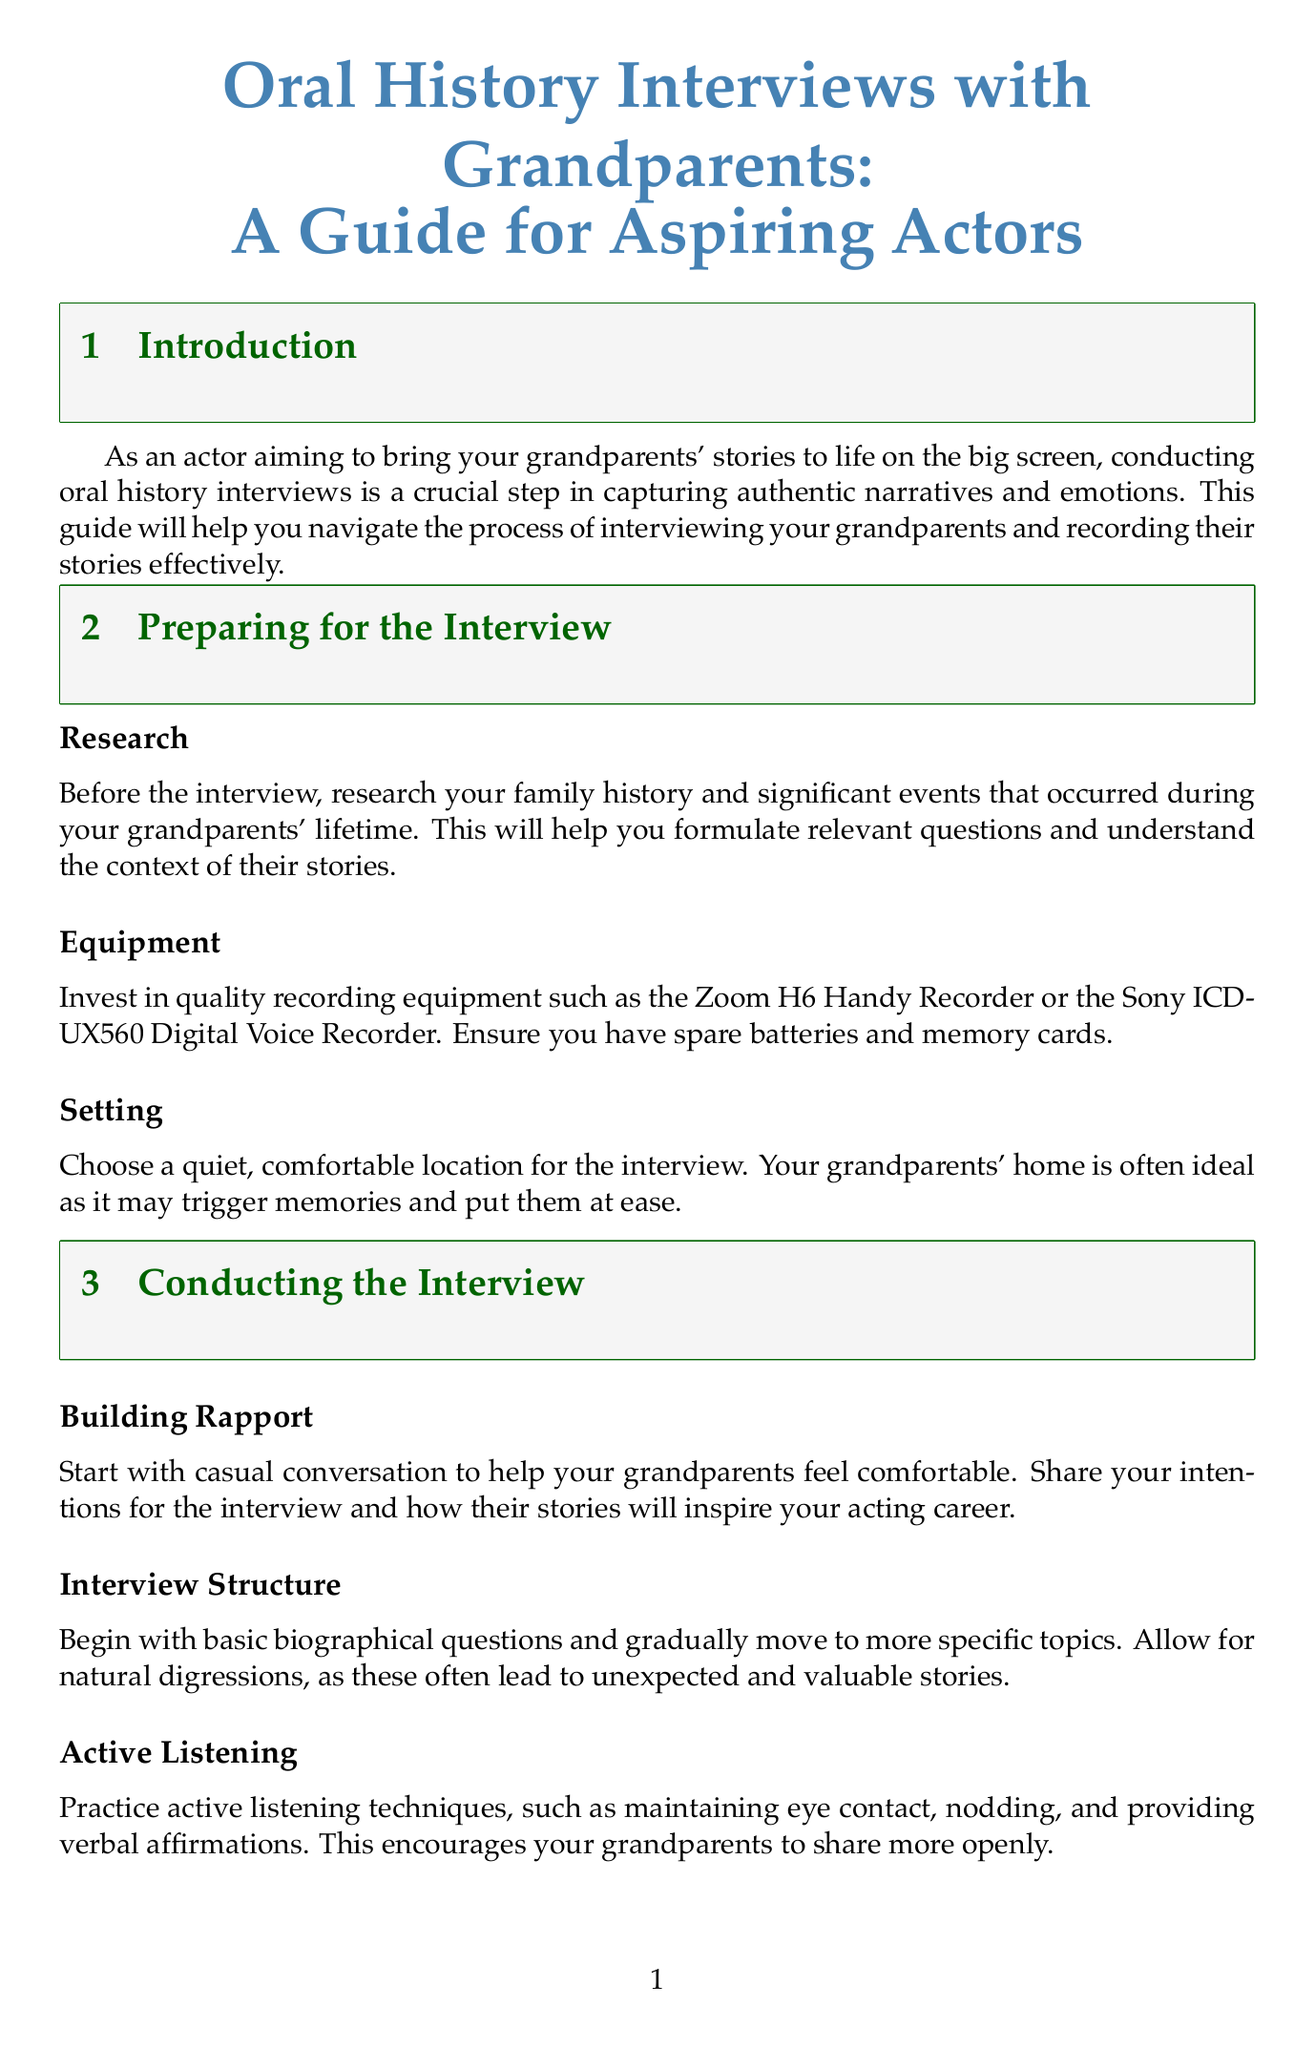What is the main purpose of the guide? The main purpose is to help aspiring actors navigate the process of interviewing their grandparents and recording their stories effectively.
Answer: capturing authentic narratives and emotions What is one recommended piece of recording equipment? The document lists quality recording equipment that should be invested in for interviews.
Answer: Zoom H6 Handy Recorder What type of location is ideal for interviews? The guide suggests a specific type of setting that often puts grandparents at ease.
Answer: grandparents' home What should you do after the interview according to the guide? The post-interview steps include certain processes that help analyze the content.
Answer: Transcribe the interview How far should the microphone be positioned from the speaker? The document provides specific guidance on microphone positioning for optimal sound quality.
Answer: 6-12 inches Which section discusses ethical considerations? This section relates to handling personal stories respectfully during the interview process.
Answer: Ethical Considerations What action can enhance character development in performance? This practice helps actors portray their characters more authentically.
Answer: Use the interviews to develop nuanced character profiles What software can be used for transcription? The document suggests a specific software for transcribing the interviews.
Answer: Otter.ai How can you ensure historical accuracy in performances? The guide emphasizes a specific approach to verify the narratives.
Answer: Cross-reference your grandparents' accounts with historical records 